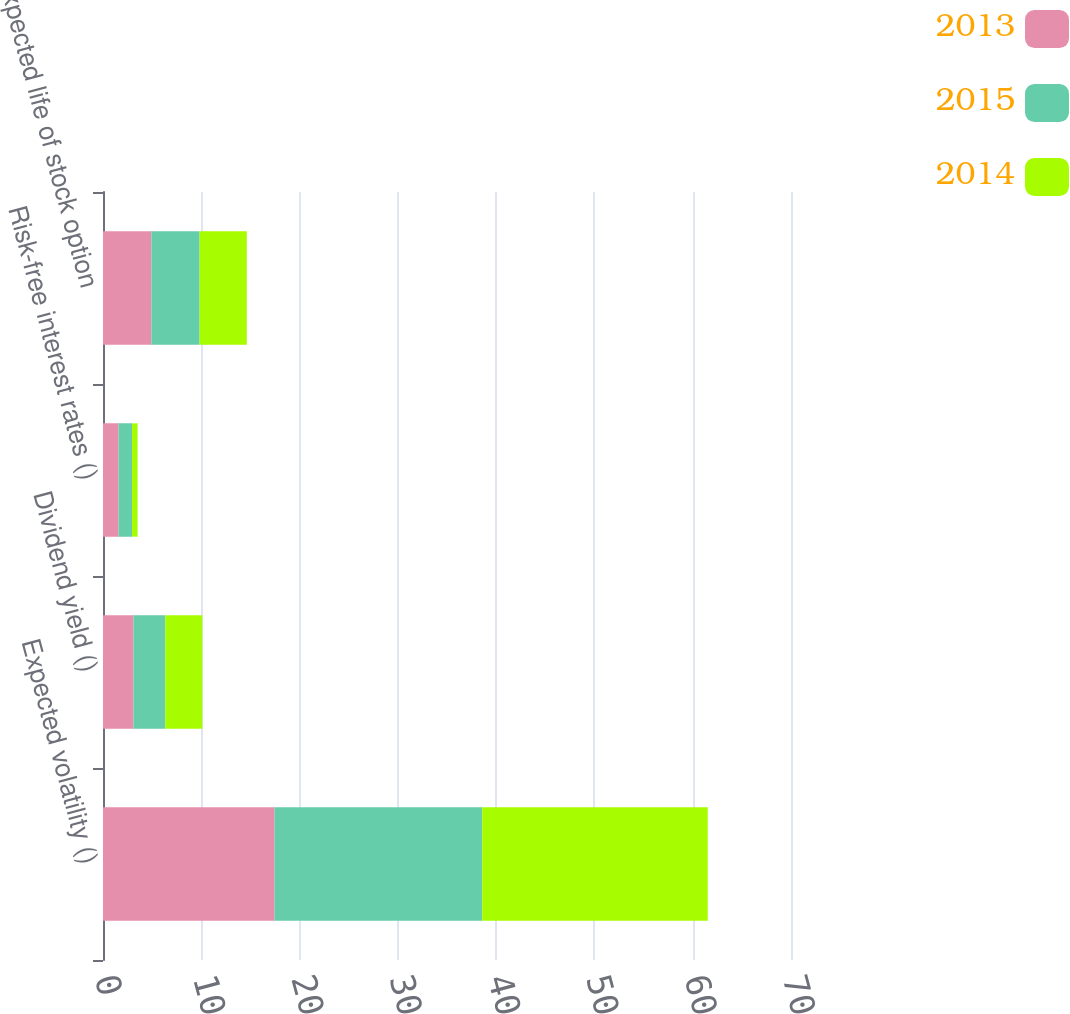Convert chart. <chart><loc_0><loc_0><loc_500><loc_500><stacked_bar_chart><ecel><fcel>Expected volatility ()<fcel>Dividend yield ()<fcel>Risk-free interest rates ()<fcel>Expected life of stock option<nl><fcel>2013<fcel>17.45<fcel>3.1<fcel>1.58<fcel>4.92<nl><fcel>2015<fcel>21.13<fcel>3.24<fcel>1.37<fcel>4.91<nl><fcel>2014<fcel>22.95<fcel>3.77<fcel>0.57<fcel>4.8<nl></chart> 